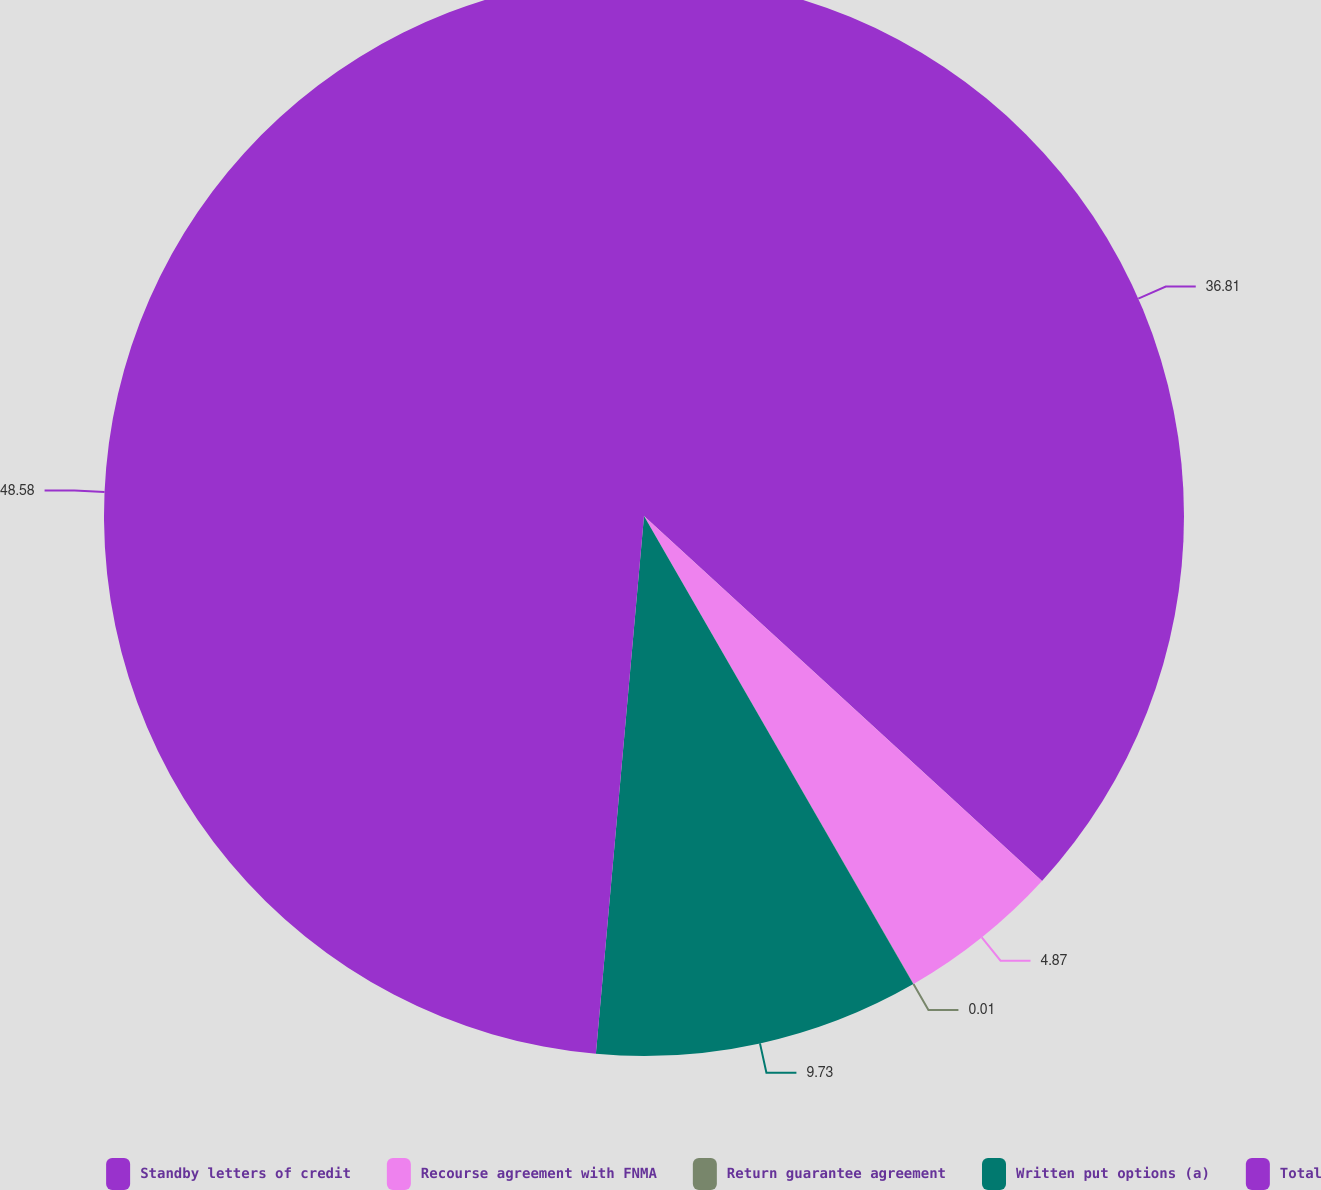<chart> <loc_0><loc_0><loc_500><loc_500><pie_chart><fcel>Standby letters of credit<fcel>Recourse agreement with FNMA<fcel>Return guarantee agreement<fcel>Written put options (a)<fcel>Total<nl><fcel>36.81%<fcel>4.87%<fcel>0.01%<fcel>9.73%<fcel>48.58%<nl></chart> 